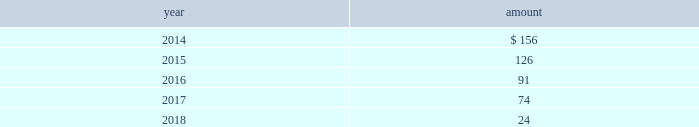The impairment tests performed for intangible assets as of july 31 , 2013 , 2012 and 2011 indicated no impairment charges were required .
Estimated amortization expense for finite-lived intangible assets for each of the five succeeding years is as follows : ( in millions ) .
Indefinite-lived acquired management contracts in july 2013 , in connection with the credit suisse etf transaction , the company acquired $ 231 million of indefinite-lived management contracts .
In march 2012 , in connection with the claymore transaction , the company acquired $ 163 million of indefinite-lived etp management contracts .
Finite-lived acquired management contracts in october 2013 , in connection with the mgpa transaction , the company acquired $ 29 million of finite-lived management contracts with a weighted-average estimated useful life of approximately eight years .
In september 2012 , in connection with the srpep transaction , the company acquired $ 40 million of finite- lived management contracts with a weighted-average estimated useful life of approximately 10 years .
11 .
Other assets at march 31 , 2013 , blackrock held an approximately one- third economic equity interest in private national mortgage acceptance company , llc ( 201cpnmac 201d ) , which is accounted for as an equity method investment and is included in other assets on the consolidated statements of financial condition .
On may 8 , 2013 , pennymac became the sole managing member of pnmac in connection with an initial public offering of pennymac ( the 201cpennymac ipo 201d ) .
As a result of the pennymac ipo , blackrock recorded a noncash , nonoperating pre-tax gain of $ 39 million related to the carrying value of its equity method investment .
Subsequent to the pennymac ipo , the company contributed 6.1 million units of its investment to a new donor advised fund ( the 201ccharitable contribution 201d ) .
The fair value of the charitable contribution was $ 124 million and is included in general and administration expenses on the consolidated statements of income .
In connection with the charitable contribution , the company also recorded a noncash , nonoperating pre-tax gain of $ 80 million related to the contributed investment and a tax benefit of approximately $ 48 million .
The carrying value and fair value of the company 2019s remaining interest ( approximately 20% ( 20 % ) or 16 million shares and units ) was approximately $ 127 million and $ 273 million , respectively , at december 31 , 2013 .
The fair value of the company 2019s interest reflected the pennymac stock price at december 31 , 2013 ( level 1 input ) .
12 .
Borrowings short-term borrowings the carrying value of short-term borrowings at december 31 , 2012 included $ 100 million under the 2012 revolving credit facility .
2013 revolving credit facility .
In march 2011 , the company entered into a five-year $ 3.5 billion unsecured revolving credit facility ( the 201c2011 credit facility 201d ) .
In march 2012 , the 2011 credit facility was amended to extend the maturity date by one year to march 2017 and in april 2012 the amount of the aggregate commitment was increased to $ 3.785 billion ( the 201c2012 credit facility 201d ) .
In march 2013 , the company 2019s credit facility was amended to extend the maturity date by one year to march 2018 and the amount of the aggregate commitment was increased to $ 3.990 billion ( the 201c2013 credit facility 201d ) .
The 2013 credit facility permits the company to request up to an additional $ 1.0 billion of borrowing capacity , subject to lender credit approval , increasing the overall size of the 2013 credit facility to an aggregate principal amount not to exceed $ 4.990 billion .
Interest on borrowings outstanding accrues at a rate based on the applicable london interbank offered rate plus a spread .
The 2013 credit facility requires the company not to exceed a maximum leverage ratio ( ratio of net debt to earnings before interest , taxes , depreciation and amortization , where net debt equals total debt less unrestricted cash ) of 3 to 1 , which was satisfied with a ratio of less than 1 to 1 at december 31 , 2013 .
The 2013 credit facility provides back- up liquidity , funds ongoing working capital for general corporate purposes and funds various investment opportunities .
At december 31 , 2013 , the company had no amount outstanding under the 2013 credit facility .
Commercial paper program .
On october 14 , 2009 , blackrock established a commercial paper program ( the 201ccp program 201d ) under which the company could issue unsecured commercial paper notes ( the 201ccp notes 201d ) on a private placement basis up to a maximum aggregate amount outstanding at any time of $ 3.0 billion .
On may 13 , 2011 , blackrock increased the maximum aggregate amount that may be borrowed under the cp program to $ 3.5 billion .
On may 17 , 2012 , blackrock increased the maximum aggregate amount to $ 3.785 billion .
In april 2013 , blackrock increased the maximum aggregate amount for which the company could issue unsecured cp notes on a private-placement basis up to a maximum aggregate amount outstanding at any time of $ 3.990 billion .
The commercial paper program is currently supported by the 2013 credit facility .
At december 31 , 2013 and 2012 , blackrock had no cp notes outstanding. .
What is the percentage increase in the maximum aggregate amount that may be borrowed under the cp program from 2009 to 2011? 
Computations: ((3.5 - 3.0) / 3.0)
Answer: 0.16667. 